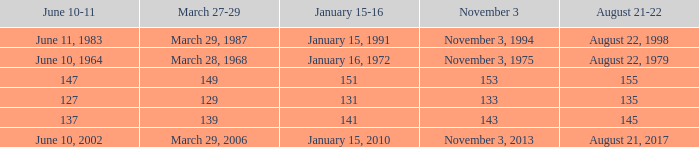What number is shown for january 15-16 when november 3 is 133? 131.0. 